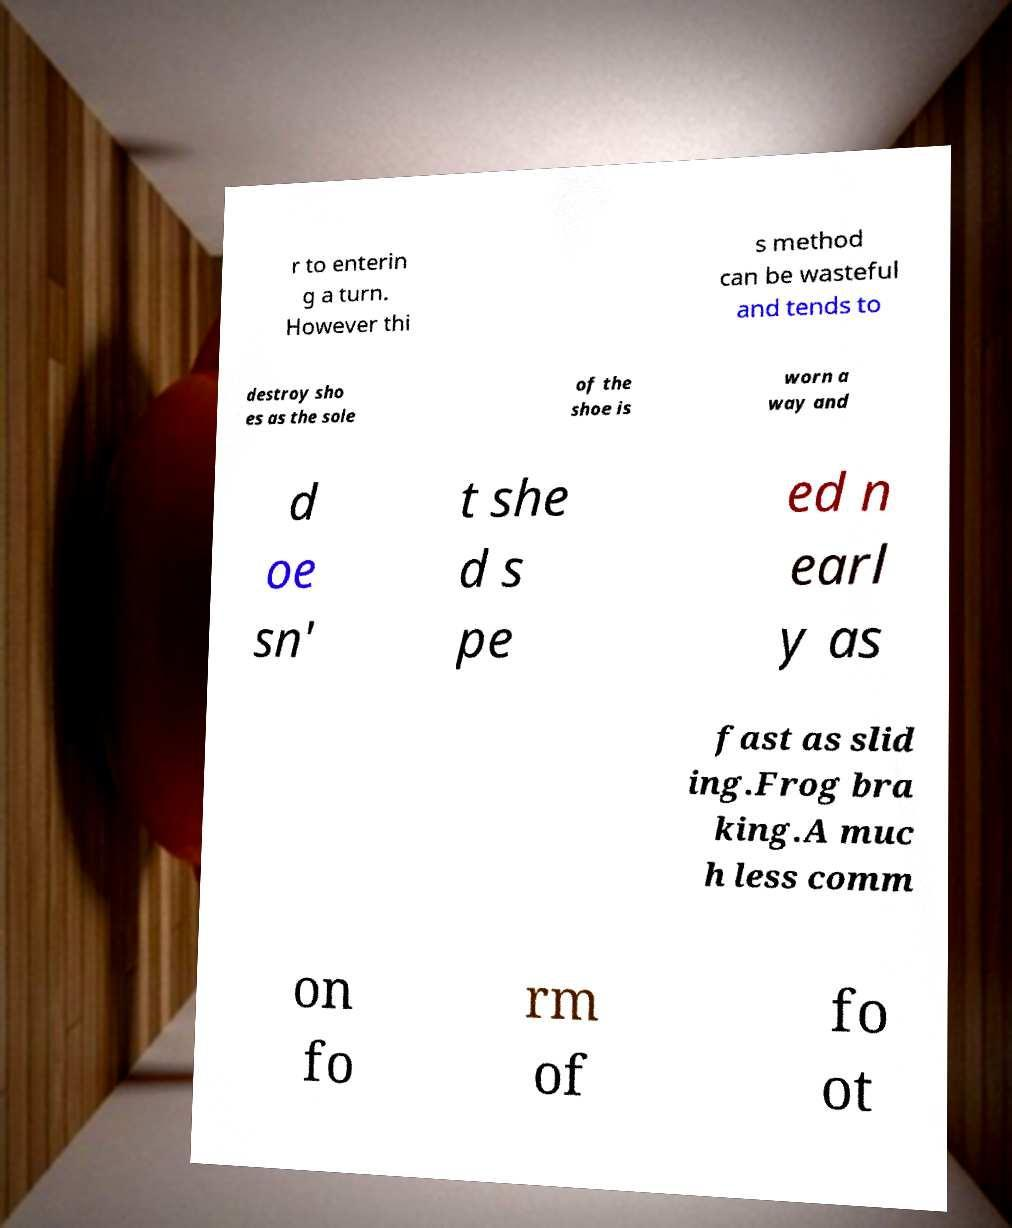What messages or text are displayed in this image? I need them in a readable, typed format. r to enterin g a turn. However thi s method can be wasteful and tends to destroy sho es as the sole of the shoe is worn a way and d oe sn' t she d s pe ed n earl y as fast as slid ing.Frog bra king.A muc h less comm on fo rm of fo ot 